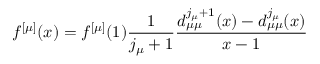Convert formula to latex. <formula><loc_0><loc_0><loc_500><loc_500>f ^ { [ \mu ] } ( x ) = f ^ { [ \mu ] } ( 1 ) \frac { 1 } { j _ { \mu } + 1 } \frac { d _ { \mu \mu } ^ { j _ { \mu } + 1 } ( x ) - d _ { \mu \mu } ^ { j _ { \mu } } ( x ) } { x - 1 }</formula> 